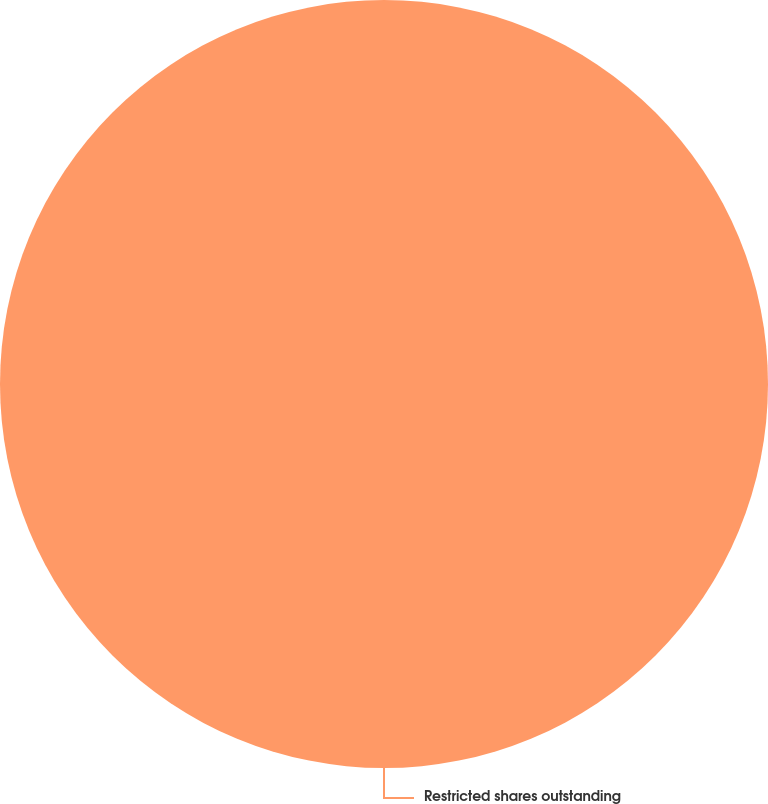Convert chart. <chart><loc_0><loc_0><loc_500><loc_500><pie_chart><fcel>Restricted shares outstanding<nl><fcel>100.0%<nl></chart> 